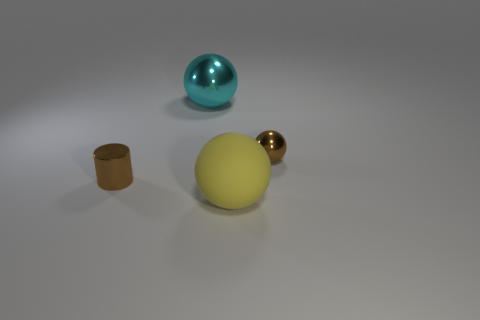Subtract all large spheres. How many spheres are left? 1 Add 3 rubber balls. How many objects exist? 7 Subtract all yellow spheres. How many spheres are left? 2 Subtract all tiny cylinders. Subtract all matte things. How many objects are left? 2 Add 2 tiny brown cylinders. How many tiny brown cylinders are left? 3 Add 2 large gray metal blocks. How many large gray metal blocks exist? 2 Subtract 0 gray blocks. How many objects are left? 4 Subtract all cylinders. How many objects are left? 3 Subtract 1 cylinders. How many cylinders are left? 0 Subtract all cyan balls. Subtract all cyan cylinders. How many balls are left? 2 